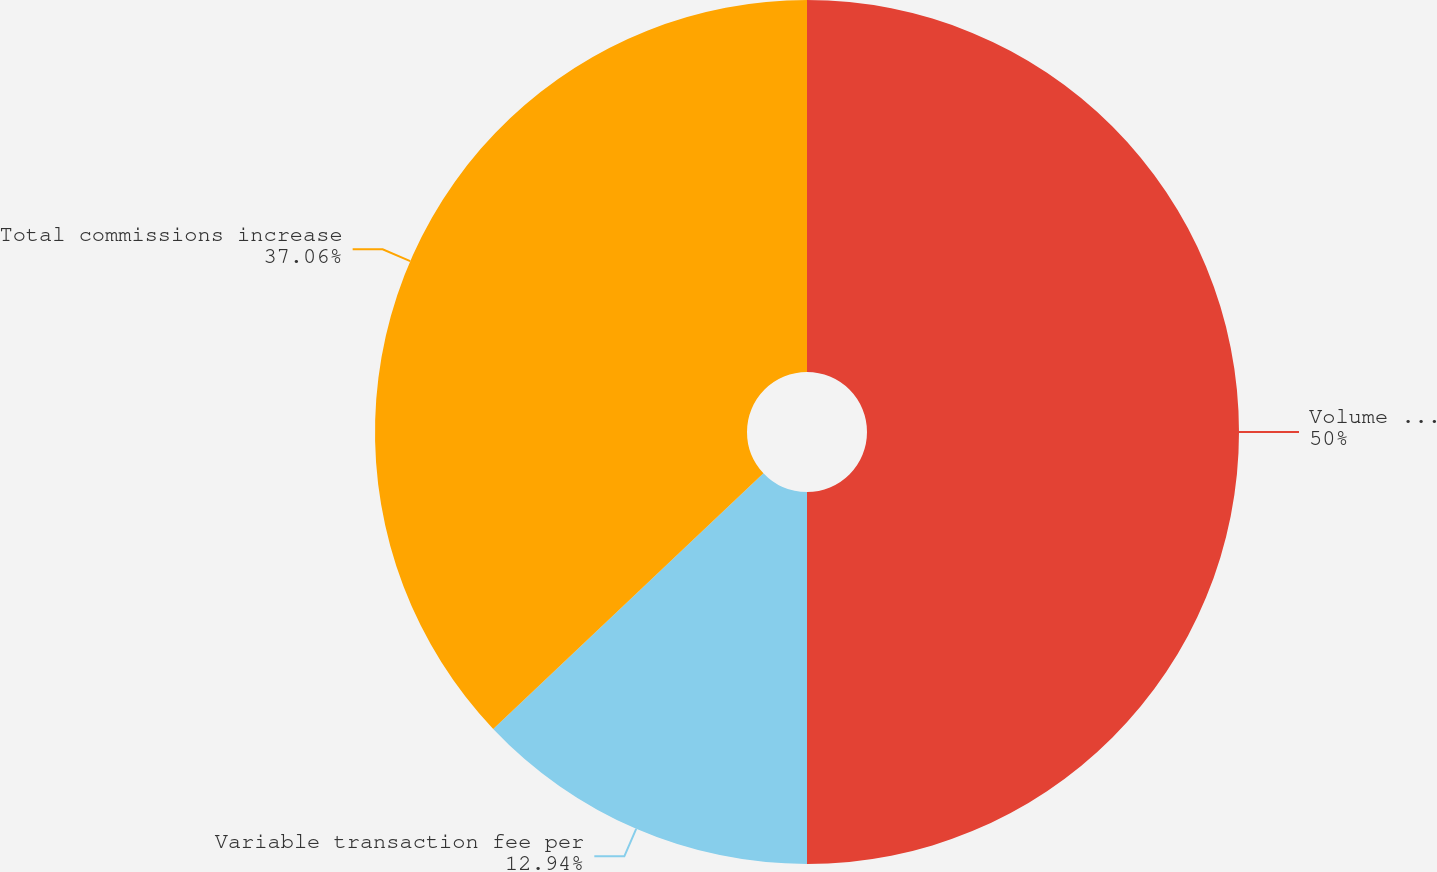Convert chart to OTSL. <chart><loc_0><loc_0><loc_500><loc_500><pie_chart><fcel>Volume increase (decrease)<fcel>Variable transaction fee per<fcel>Total commissions increase<nl><fcel>50.0%<fcel>12.94%<fcel>37.06%<nl></chart> 